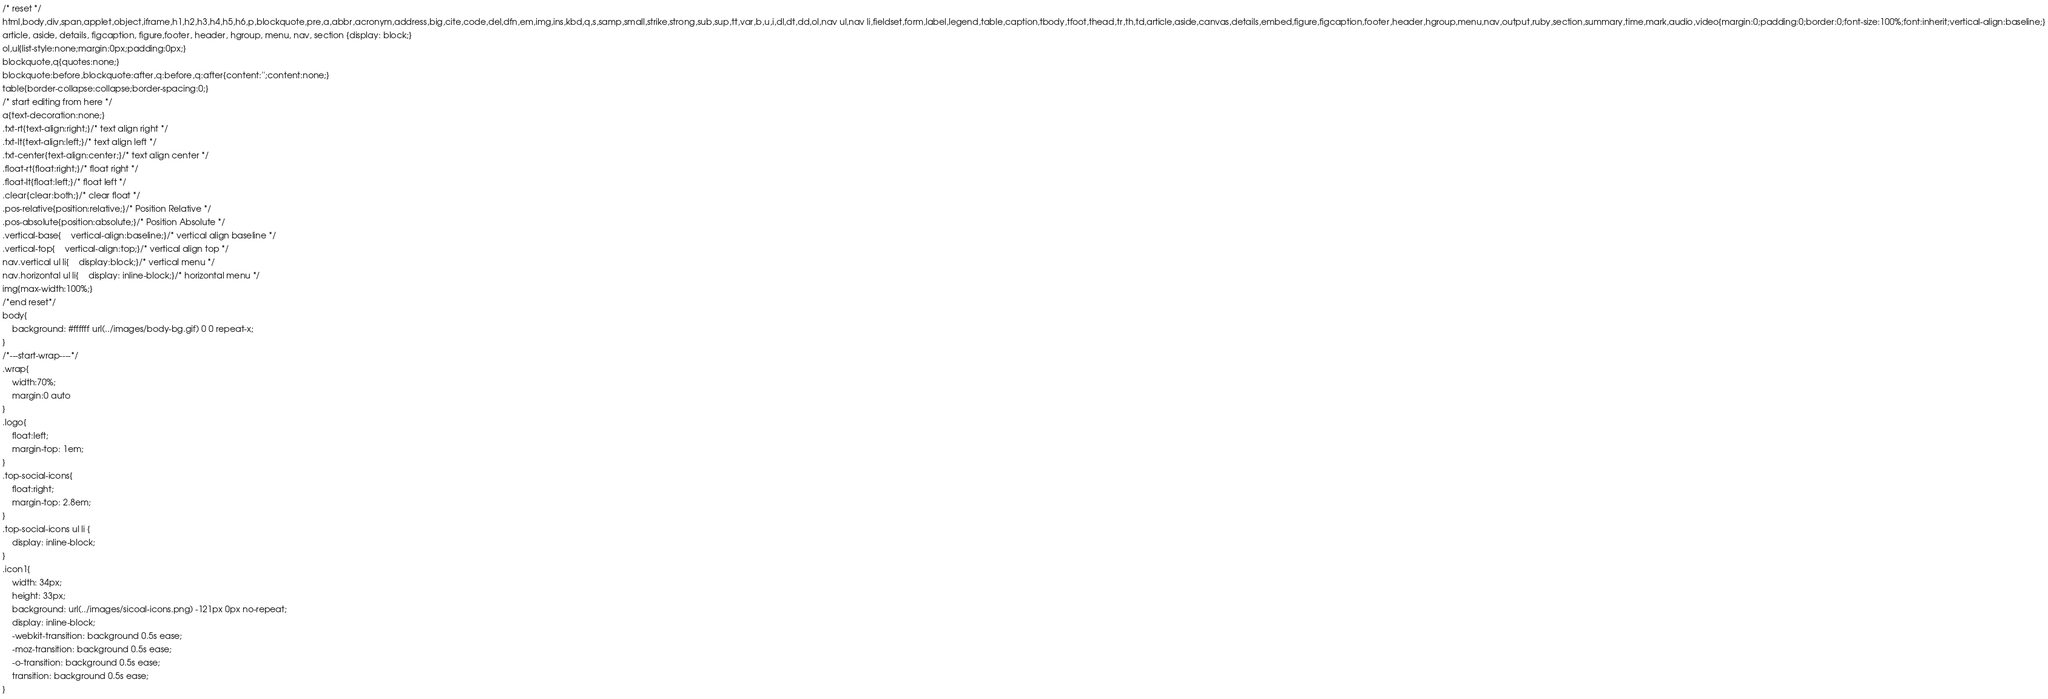<code> <loc_0><loc_0><loc_500><loc_500><_CSS_>/* reset */
html,body,div,span,applet,object,iframe,h1,h2,h3,h4,h5,h6,p,blockquote,pre,a,abbr,acronym,address,big,cite,code,del,dfn,em,img,ins,kbd,q,s,samp,small,strike,strong,sub,sup,tt,var,b,u,i,dl,dt,dd,ol,nav ul,nav li,fieldset,form,label,legend,table,caption,tbody,tfoot,thead,tr,th,td,article,aside,canvas,details,embed,figure,figcaption,footer,header,hgroup,menu,nav,output,ruby,section,summary,time,mark,audio,video{margin:0;padding:0;border:0;font-size:100%;font:inherit;vertical-align:baseline;}
article, aside, details, figcaption, figure,footer, header, hgroup, menu, nav, section {display: block;}
ol,ul{list-style:none;margin:0px;padding:0px;}
blockquote,q{quotes:none;}
blockquote:before,blockquote:after,q:before,q:after{content:'';content:none;}
table{border-collapse:collapse;border-spacing:0;}
/* start editing from here */
a{text-decoration:none;}
.txt-rt{text-align:right;}/* text align right */
.txt-lt{text-align:left;}/* text align left */
.txt-center{text-align:center;}/* text align center */
.float-rt{float:right;}/* float right */
.float-lt{float:left;}/* float left */
.clear{clear:both;}/* clear float */
.pos-relative{position:relative;}/* Position Relative */
.pos-absolute{position:absolute;}/* Position Absolute */
.vertical-base{	vertical-align:baseline;}/* vertical align baseline */
.vertical-top{	vertical-align:top;}/* vertical align top */
nav.vertical ul li{	display:block;}/* vertical menu */
nav.horizontal ul li{	display: inline-block;}/* horizontal menu */
img{max-width:100%;}
/*end reset*/
body{
	background: #ffffff url(../images/body-bg.gif) 0 0 repeat-x;
}
/*---start-wrap----*/
.wrap{
	width:70%;
	margin:0 auto
}
.logo{
	float:left;
	margin-top: 1em;
}
.top-social-icons{
	float:right;
	margin-top: 2.8em;
}
.top-social-icons ul li {
	display: inline-block;
}
.icon1{
	width: 34px;
	height: 33px;
	background: url(../images/sicoal-icons.png) -121px 0px no-repeat;
	display: inline-block;
	-webkit-transition: background 0.5s ease;
	-moz-transition: background 0.5s ease;
	-o-transition: background 0.5s ease;
	transition: background 0.5s ease;
}</code> 